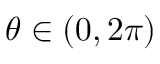<formula> <loc_0><loc_0><loc_500><loc_500>\theta \in ( 0 , 2 \pi )</formula> 